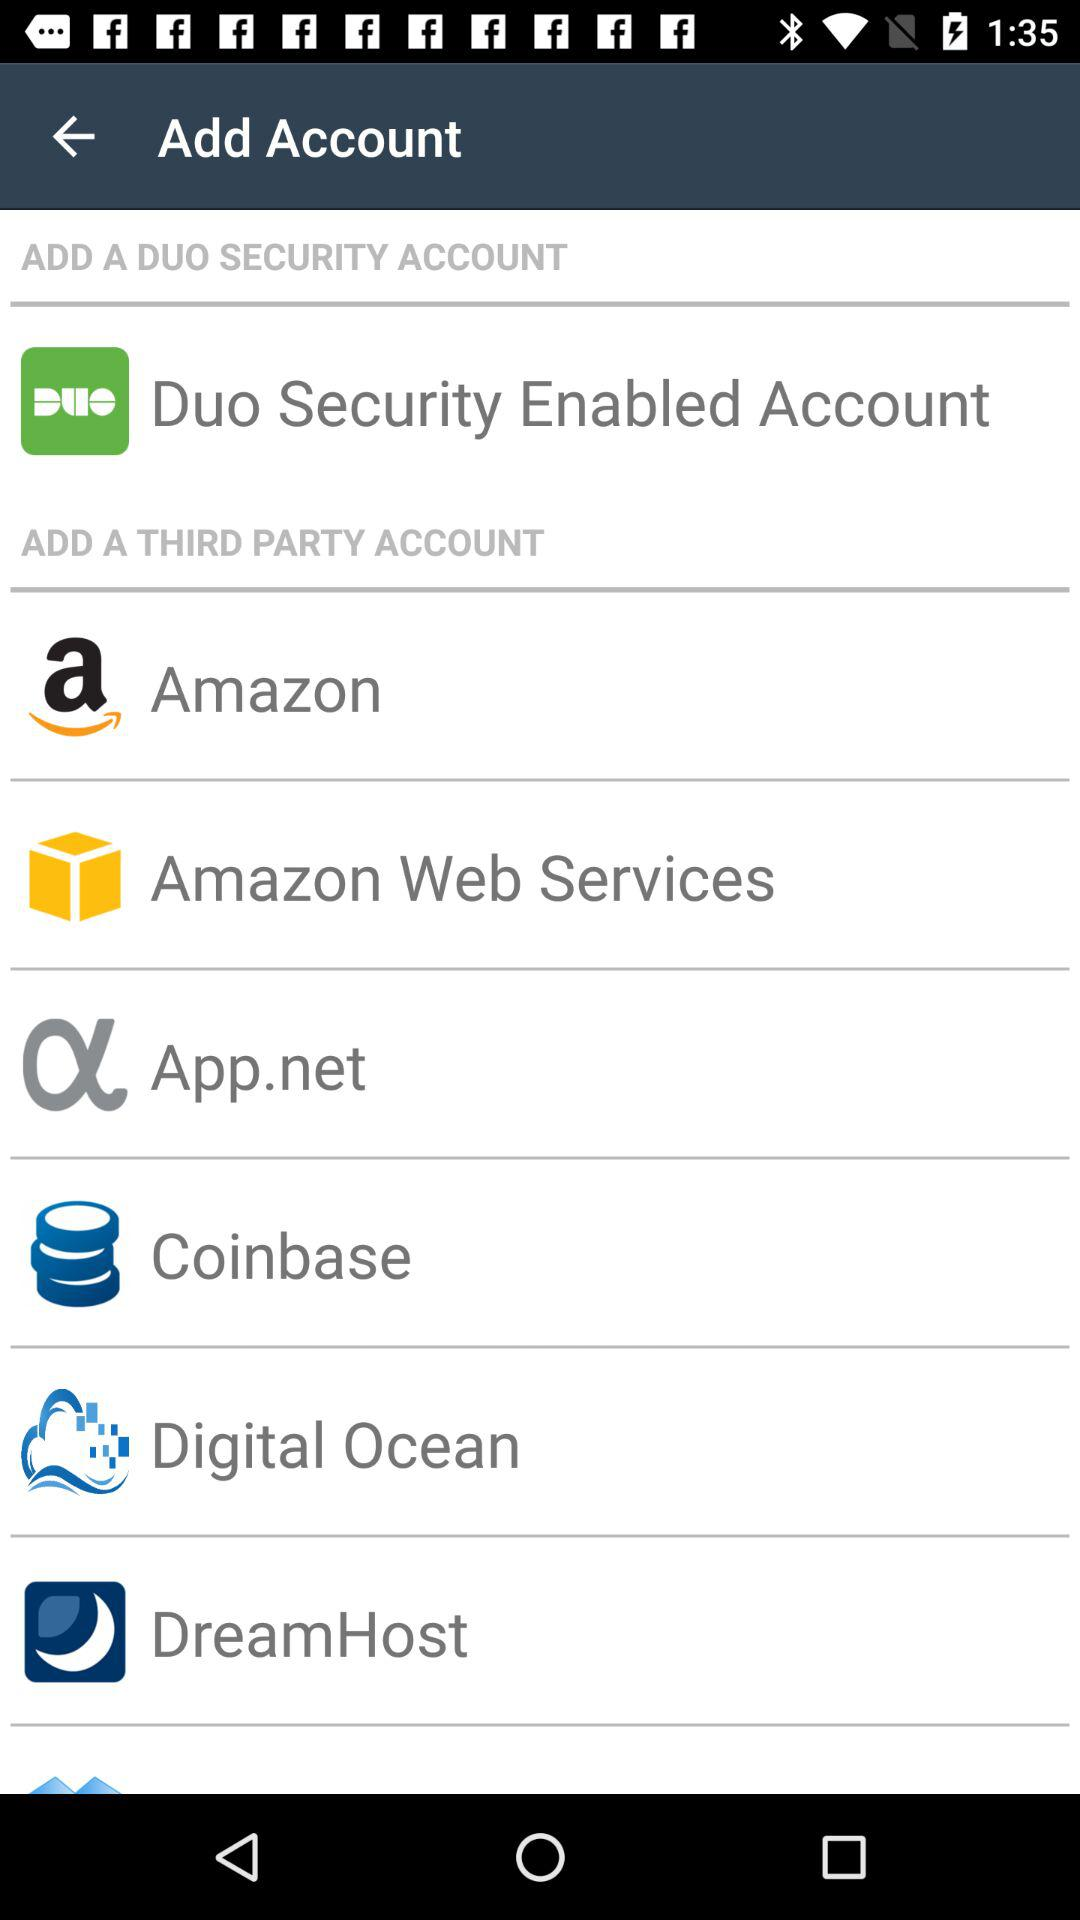What are the different third-party accounts available? The available third-party accounts are "Amazon", "Amazon Web Services", "App.net", "Coinbase", "Digital Ocean" and "DreamHost". 